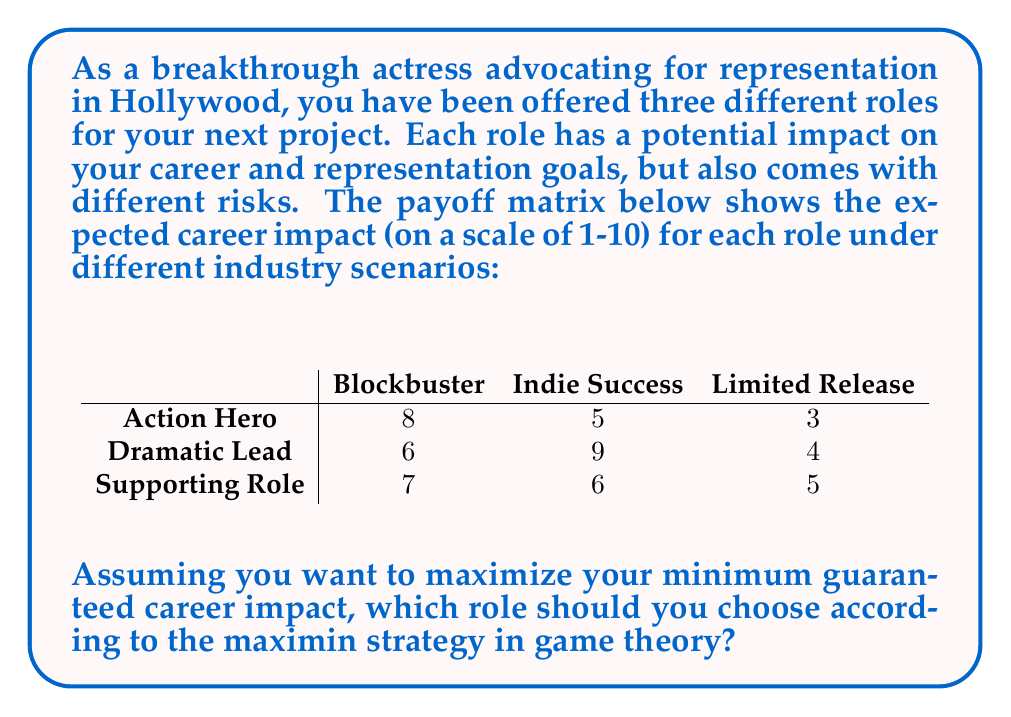Teach me how to tackle this problem. To solve this problem using the maximin strategy from game theory, we need to follow these steps:

1. Identify the minimum payoff for each role:
   - Action Hero: $\min(8, 5, 3) = 3$
   - Dramatic Lead: $\min(6, 9, 4) = 4$
   - Supporting Role: $\min(7, 6, 5) = 5$

2. The maximin strategy suggests choosing the role that maximizes the minimum guaranteed payoff. This approach ensures the best worst-case scenario outcome.

3. Compare the minimum payoffs:
   $\max(3, 4, 5) = 5$

4. The role with the highest minimum payoff is the Supporting Role, with a guaranteed minimum impact of 5.

This strategy aligns with the persona of an actress advocating for representation in Hollywood. By choosing the Supporting Role, the actress ensures a consistent positive impact across all industry scenarios, potentially allowing for more diverse and impactful roles in the long run, even if they're not always the lead character.
Answer: The optimal choice according to the maximin strategy is the Supporting Role, with a guaranteed minimum career impact of 5. 